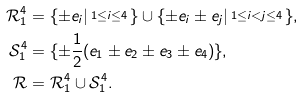Convert formula to latex. <formula><loc_0><loc_0><loc_500><loc_500>\mathcal { R } ^ { 4 } _ { 1 } & = \{ \pm { e } _ { i } | \begin{smallmatrix} 1 \leq { i } \leq { 4 } \end{smallmatrix} \} \cup \{ \pm { e } _ { i } \pm { e } _ { j } | \begin{smallmatrix} 1 \leq { i } < j \leq { 4 } \end{smallmatrix} \} , \\ \mathcal { S } ^ { 4 } _ { 1 } & = \{ \pm \frac { 1 } { 2 } ( e _ { 1 } \pm { e } _ { 2 } \pm { e } _ { 3 } \pm { e } _ { 4 } ) \} , \\ \mathcal { R } & = \mathcal { R } ^ { 4 } _ { 1 } \cup \mathcal { S } ^ { 4 } _ { 1 } .</formula> 